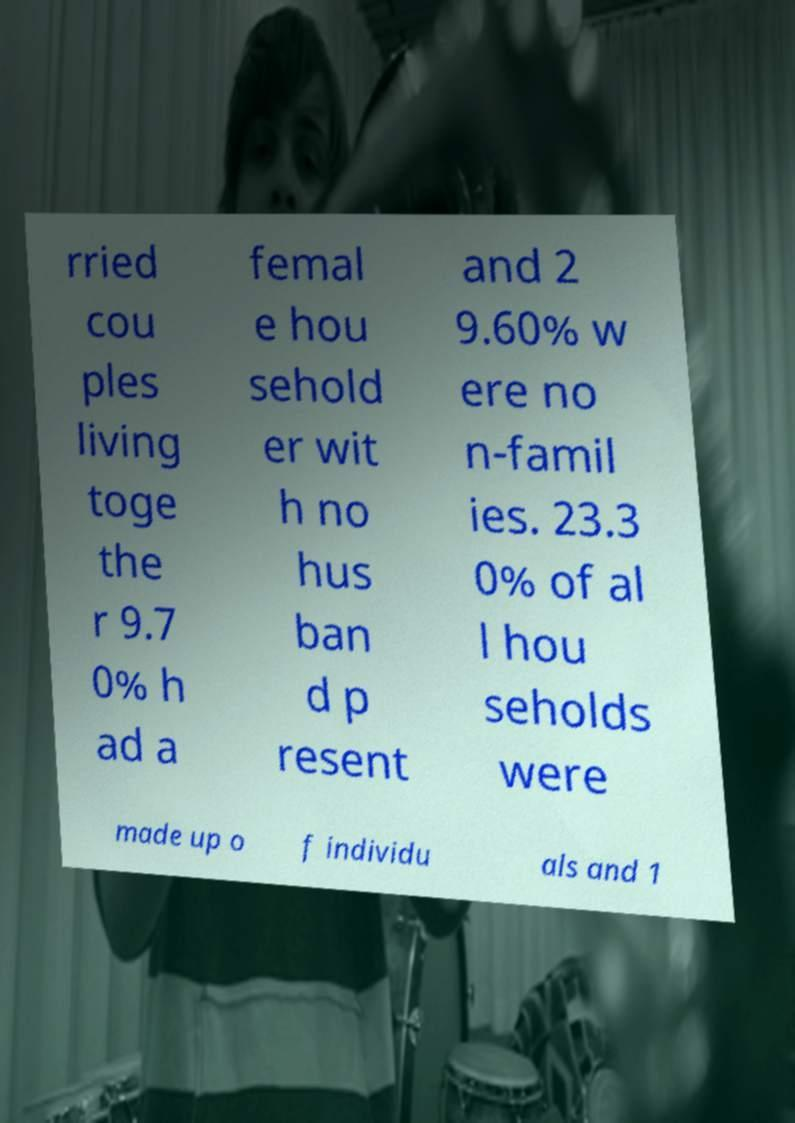Can you read and provide the text displayed in the image?This photo seems to have some interesting text. Can you extract and type it out for me? rried cou ples living toge the r 9.7 0% h ad a femal e hou sehold er wit h no hus ban d p resent and 2 9.60% w ere no n-famil ies. 23.3 0% of al l hou seholds were made up o f individu als and 1 